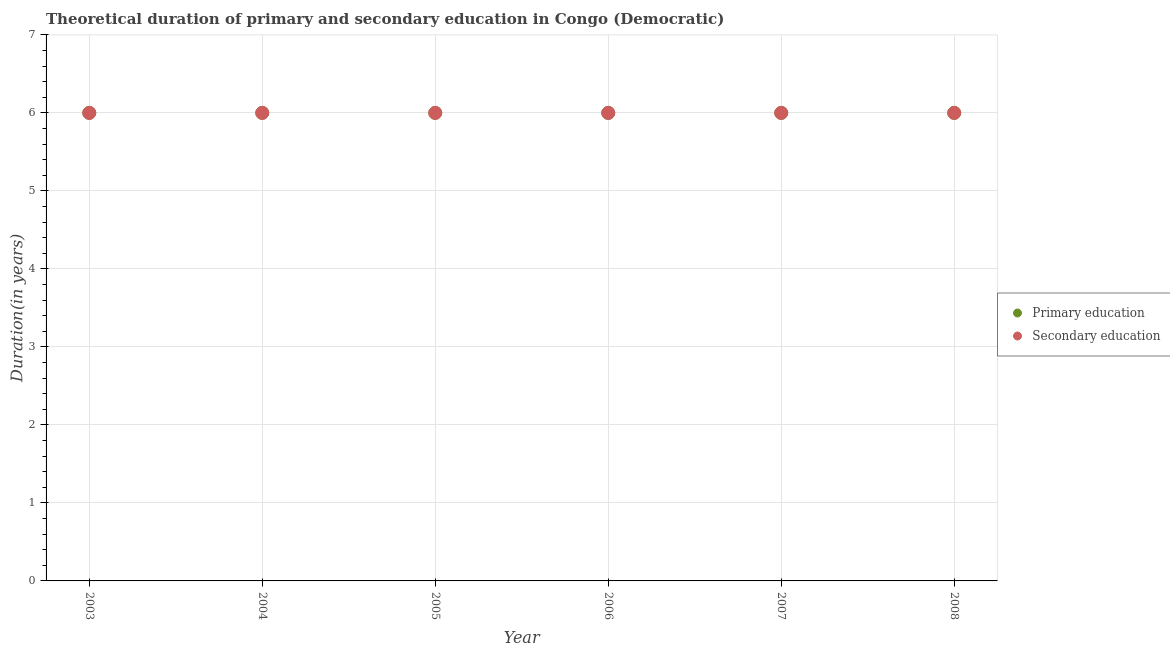How many different coloured dotlines are there?
Keep it short and to the point. 2. Is the number of dotlines equal to the number of legend labels?
Provide a short and direct response. Yes. What is the duration of secondary education in 2007?
Provide a short and direct response. 6. Across all years, what is the maximum duration of secondary education?
Make the answer very short. 6. Across all years, what is the minimum duration of secondary education?
Provide a succinct answer. 6. In which year was the duration of primary education maximum?
Give a very brief answer. 2003. What is the total duration of secondary education in the graph?
Provide a succinct answer. 36. What is the difference between the duration of secondary education in 2003 and that in 2007?
Ensure brevity in your answer.  0. What is the difference between the duration of primary education in 2006 and the duration of secondary education in 2008?
Offer a terse response. 0. In the year 2005, what is the difference between the duration of secondary education and duration of primary education?
Give a very brief answer. 0. What is the difference between the highest and the lowest duration of secondary education?
Provide a short and direct response. 0. Does the duration of secondary education monotonically increase over the years?
Your response must be concise. No. Is the duration of secondary education strictly greater than the duration of primary education over the years?
Your response must be concise. No. What is the difference between two consecutive major ticks on the Y-axis?
Make the answer very short. 1. Are the values on the major ticks of Y-axis written in scientific E-notation?
Make the answer very short. No. Does the graph contain grids?
Offer a very short reply. Yes. How many legend labels are there?
Make the answer very short. 2. How are the legend labels stacked?
Provide a succinct answer. Vertical. What is the title of the graph?
Keep it short and to the point. Theoretical duration of primary and secondary education in Congo (Democratic). Does "Commercial service imports" appear as one of the legend labels in the graph?
Your response must be concise. No. What is the label or title of the X-axis?
Offer a very short reply. Year. What is the label or title of the Y-axis?
Your answer should be very brief. Duration(in years). What is the Duration(in years) of Primary education in 2003?
Offer a terse response. 6. What is the Duration(in years) of Secondary education in 2003?
Your response must be concise. 6. What is the Duration(in years) of Primary education in 2004?
Keep it short and to the point. 6. What is the Duration(in years) of Secondary education in 2007?
Provide a succinct answer. 6. Across all years, what is the maximum Duration(in years) in Primary education?
Provide a short and direct response. 6. Across all years, what is the maximum Duration(in years) in Secondary education?
Offer a terse response. 6. Across all years, what is the minimum Duration(in years) of Secondary education?
Offer a very short reply. 6. What is the total Duration(in years) in Secondary education in the graph?
Provide a short and direct response. 36. What is the difference between the Duration(in years) of Primary education in 2003 and that in 2005?
Keep it short and to the point. 0. What is the difference between the Duration(in years) in Secondary education in 2003 and that in 2005?
Your answer should be very brief. 0. What is the difference between the Duration(in years) of Secondary education in 2003 and that in 2006?
Provide a succinct answer. 0. What is the difference between the Duration(in years) in Primary education in 2003 and that in 2007?
Offer a terse response. 0. What is the difference between the Duration(in years) of Primary education in 2003 and that in 2008?
Give a very brief answer. 0. What is the difference between the Duration(in years) of Secondary education in 2003 and that in 2008?
Your response must be concise. 0. What is the difference between the Duration(in years) in Primary education in 2004 and that in 2005?
Make the answer very short. 0. What is the difference between the Duration(in years) of Secondary education in 2004 and that in 2007?
Keep it short and to the point. 0. What is the difference between the Duration(in years) in Primary education in 2004 and that in 2008?
Your answer should be very brief. 0. What is the difference between the Duration(in years) in Primary education in 2005 and that in 2006?
Your answer should be very brief. 0. What is the difference between the Duration(in years) in Secondary education in 2005 and that in 2006?
Your response must be concise. 0. What is the difference between the Duration(in years) in Primary education in 2005 and that in 2007?
Offer a very short reply. 0. What is the difference between the Duration(in years) in Secondary education in 2005 and that in 2007?
Offer a very short reply. 0. What is the difference between the Duration(in years) of Primary education in 2005 and that in 2008?
Your answer should be compact. 0. What is the difference between the Duration(in years) of Secondary education in 2005 and that in 2008?
Ensure brevity in your answer.  0. What is the difference between the Duration(in years) in Primary education in 2006 and that in 2007?
Your response must be concise. 0. What is the difference between the Duration(in years) in Primary education in 2006 and that in 2008?
Offer a terse response. 0. What is the difference between the Duration(in years) of Primary education in 2007 and that in 2008?
Offer a very short reply. 0. What is the difference between the Duration(in years) in Primary education in 2003 and the Duration(in years) in Secondary education in 2004?
Your response must be concise. 0. What is the difference between the Duration(in years) of Primary education in 2003 and the Duration(in years) of Secondary education in 2005?
Provide a short and direct response. 0. What is the difference between the Duration(in years) in Primary education in 2003 and the Duration(in years) in Secondary education in 2006?
Ensure brevity in your answer.  0. What is the difference between the Duration(in years) in Primary education in 2003 and the Duration(in years) in Secondary education in 2007?
Ensure brevity in your answer.  0. What is the difference between the Duration(in years) of Primary education in 2003 and the Duration(in years) of Secondary education in 2008?
Offer a very short reply. 0. What is the difference between the Duration(in years) in Primary education in 2004 and the Duration(in years) in Secondary education in 2005?
Your response must be concise. 0. What is the difference between the Duration(in years) in Primary education in 2004 and the Duration(in years) in Secondary education in 2007?
Your answer should be very brief. 0. What is the difference between the Duration(in years) in Primary education in 2005 and the Duration(in years) in Secondary education in 2007?
Ensure brevity in your answer.  0. What is the average Duration(in years) of Primary education per year?
Give a very brief answer. 6. What is the average Duration(in years) of Secondary education per year?
Give a very brief answer. 6. In the year 2005, what is the difference between the Duration(in years) in Primary education and Duration(in years) in Secondary education?
Provide a short and direct response. 0. In the year 2007, what is the difference between the Duration(in years) of Primary education and Duration(in years) of Secondary education?
Ensure brevity in your answer.  0. What is the ratio of the Duration(in years) of Primary education in 2003 to that in 2004?
Keep it short and to the point. 1. What is the ratio of the Duration(in years) in Primary education in 2003 to that in 2005?
Your response must be concise. 1. What is the ratio of the Duration(in years) of Primary education in 2003 to that in 2006?
Provide a succinct answer. 1. What is the ratio of the Duration(in years) in Secondary education in 2003 to that in 2006?
Give a very brief answer. 1. What is the ratio of the Duration(in years) in Primary education in 2003 to that in 2008?
Provide a short and direct response. 1. What is the ratio of the Duration(in years) in Secondary education in 2003 to that in 2008?
Offer a terse response. 1. What is the ratio of the Duration(in years) of Secondary education in 2004 to that in 2005?
Provide a succinct answer. 1. What is the ratio of the Duration(in years) in Primary education in 2004 to that in 2006?
Your answer should be very brief. 1. What is the ratio of the Duration(in years) in Secondary education in 2004 to that in 2007?
Keep it short and to the point. 1. What is the ratio of the Duration(in years) of Secondary education in 2004 to that in 2008?
Keep it short and to the point. 1. What is the ratio of the Duration(in years) in Secondary education in 2005 to that in 2007?
Your answer should be compact. 1. What is the ratio of the Duration(in years) in Primary education in 2005 to that in 2008?
Make the answer very short. 1. What is the ratio of the Duration(in years) in Secondary education in 2006 to that in 2007?
Give a very brief answer. 1. What is the ratio of the Duration(in years) in Primary education in 2006 to that in 2008?
Offer a terse response. 1. What is the difference between the highest and the second highest Duration(in years) of Primary education?
Provide a short and direct response. 0. What is the difference between the highest and the second highest Duration(in years) in Secondary education?
Your answer should be very brief. 0. 